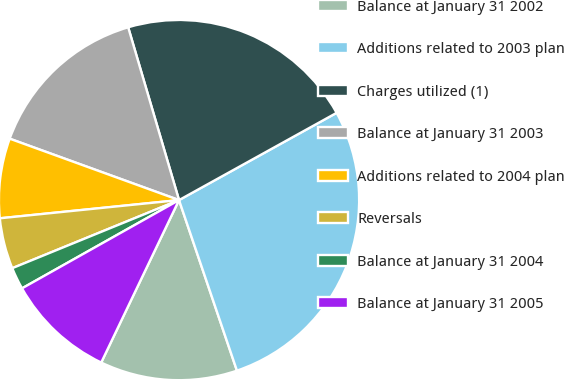<chart> <loc_0><loc_0><loc_500><loc_500><pie_chart><fcel>Balance at January 31 2002<fcel>Additions related to 2003 plan<fcel>Charges utilized (1)<fcel>Balance at January 31 2003<fcel>Additions related to 2004 plan<fcel>Reversals<fcel>Balance at January 31 2004<fcel>Balance at January 31 2005<nl><fcel>12.32%<fcel>27.84%<fcel>21.51%<fcel>14.91%<fcel>7.15%<fcel>4.56%<fcel>1.98%<fcel>9.74%<nl></chart> 